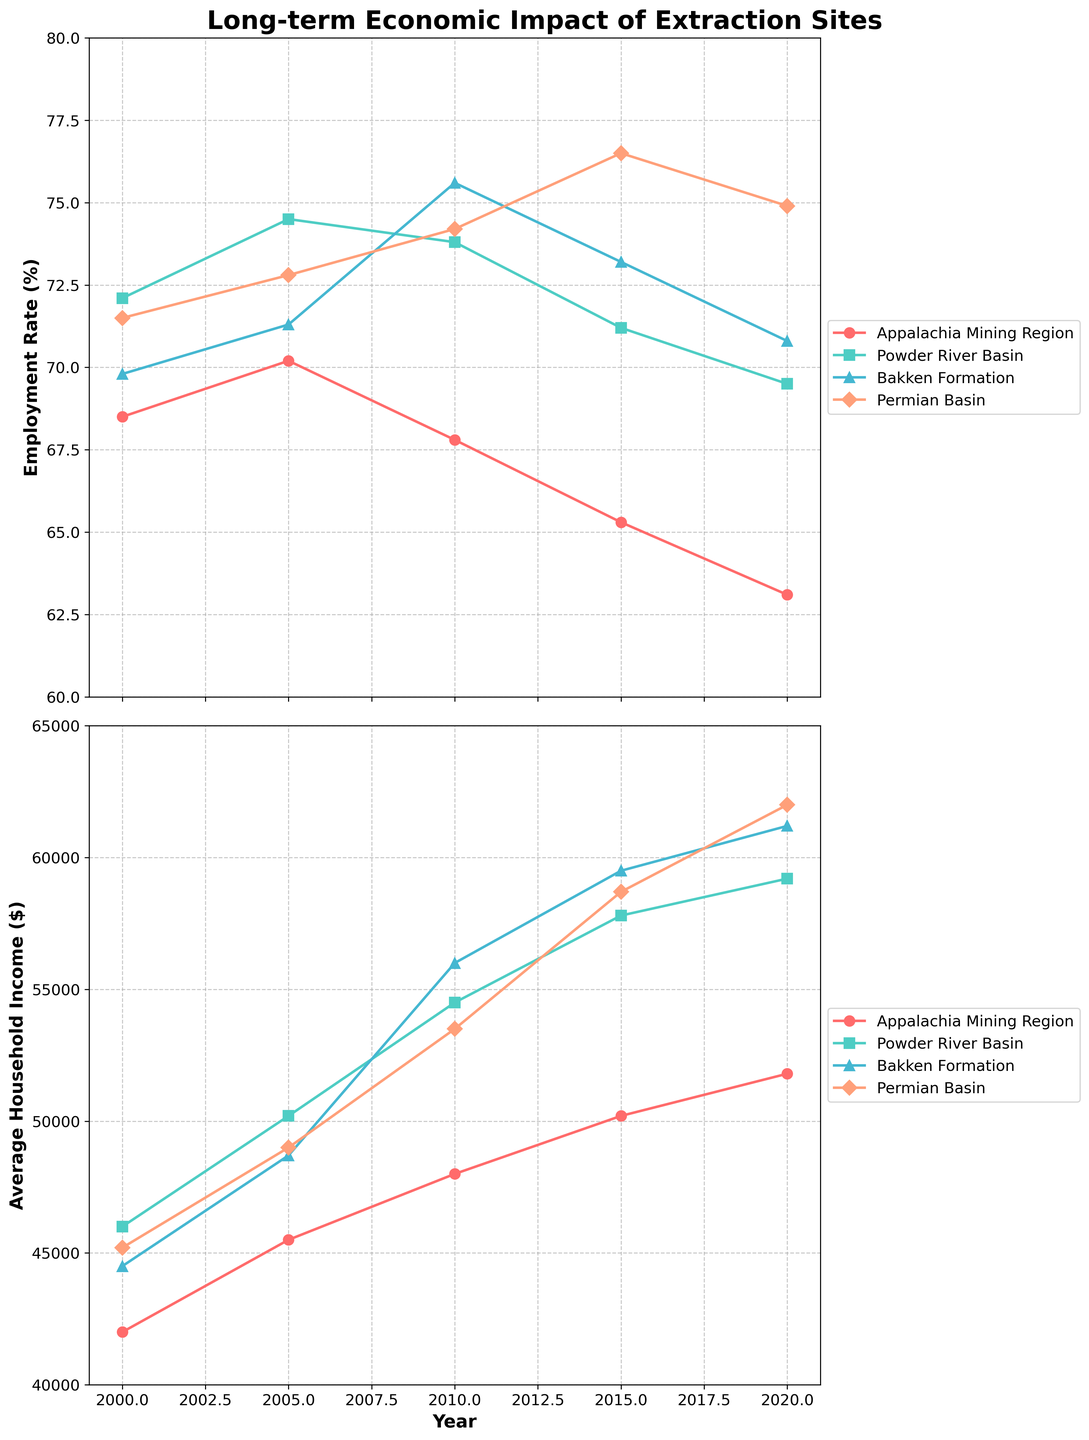What's the overall trend in employment rates in the Appalachia Mining Region from 2000 to 2020? From the figure, observe the line corresponding to the Appalachia Mining Region. Notice that the employment rate starts at 68.5% in 2000 and gradually declines to 63.1% by 2020. This indicates a downward trend over the 20-year period.
Answer: Downward trend Which region had the highest average household income in 2020? Check the lines corresponding to average household income for all regions in the year 2020. The Permian Basin shows the highest value at $62,000 in 2020.
Answer: Permian Basin What's the difference in employment rates between the Bakken Formation and the Powder River Basin in 2010? Note the employment rate of the Bakken Formation (75.6%) and the Powder River Basin (73.8%) in 2010. Calculate the difference: 75.6% - 73.8% = 1.8%.
Answer: 1.8% Which region experienced the largest decline in employment rate from 2000 to 2020? Observe the starting and ending points of the employment rate lines for all regions. Calculate the difference for each: 
Appalachia Mining Region: 68.5% - 63.1% = 5.4%,
Powder River Basin: 72.1% - 69.5% = 2.6%,
Bakken Formation: 69.8% - 70.8% = -1% (increase),
Permian Basin: 71.5% - 74.9% = -3.4% (increase).
The largest decline is in the Appalachia Mining Region.
Answer: Appalachia Mining Region Did the average household income in the Bakken Formation ever surpass that in the Permian Basin over the given time period? Compare the lines corresponding to average household income for Bakken Formation and Permian Basin. At no point does the Bakken Formation line go above the Permian Basin line.
Answer: No What is the average employment rate in the Permian Basin from 2000 to 2020? Sum the employment rates for the Permian Basin for each year: (71.5 + 72.8 + 74.2 + 76.5 + 74.9) = 370. Sum the years: 370. Divide the sum by the number of years (5): 370 / 5 = 74%.
Answer: 74% Compare the rate of increase in household incomes between 2000 and 2010 for the Appalachia Mining Region and the Bakken Formation. Calculate the differences in household incomes from 2000 to 2010 for both regions:
Appalachia Mining Region: $48,000 - $42,000 = $6,000,
Bakken Formation: $56,000 - $44,500 = $11,500.
Now, compare the differences: $11,500 (Bakken) is greater than $6,000 (Appalachia).
Answer: Bakken Formation had a higher increase Which region has the most consistent employment rate over time from 2000 to 2020? Compare the fluctuations in employment rates for each region. The region with the least fluctuations is the Powder River Basin, where the rates fluctuate moderately around the 70s range.
Answer: Powder River Basin 